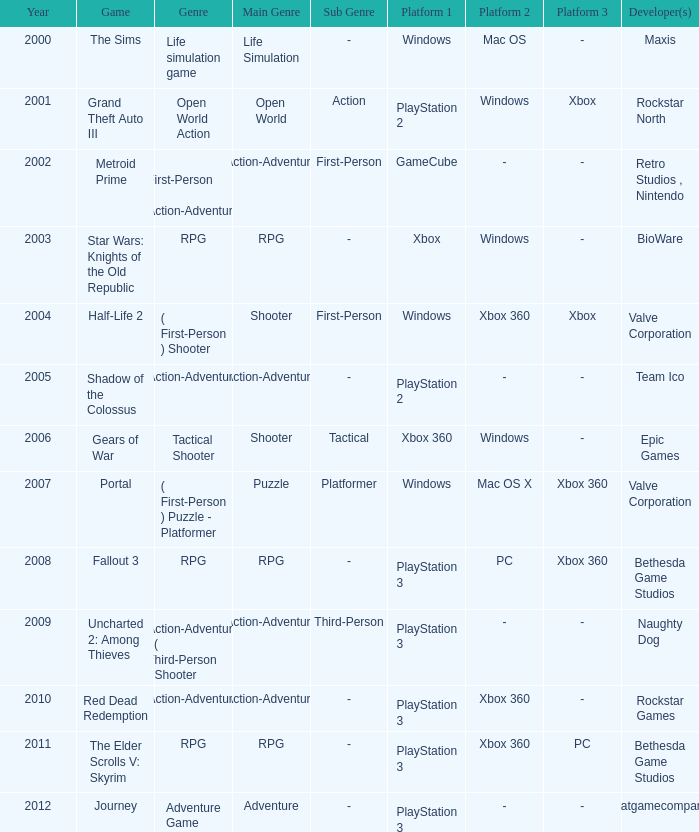What's the platform that has Rockstar Games as the developer? PlayStation 3 , Xbox 360. 